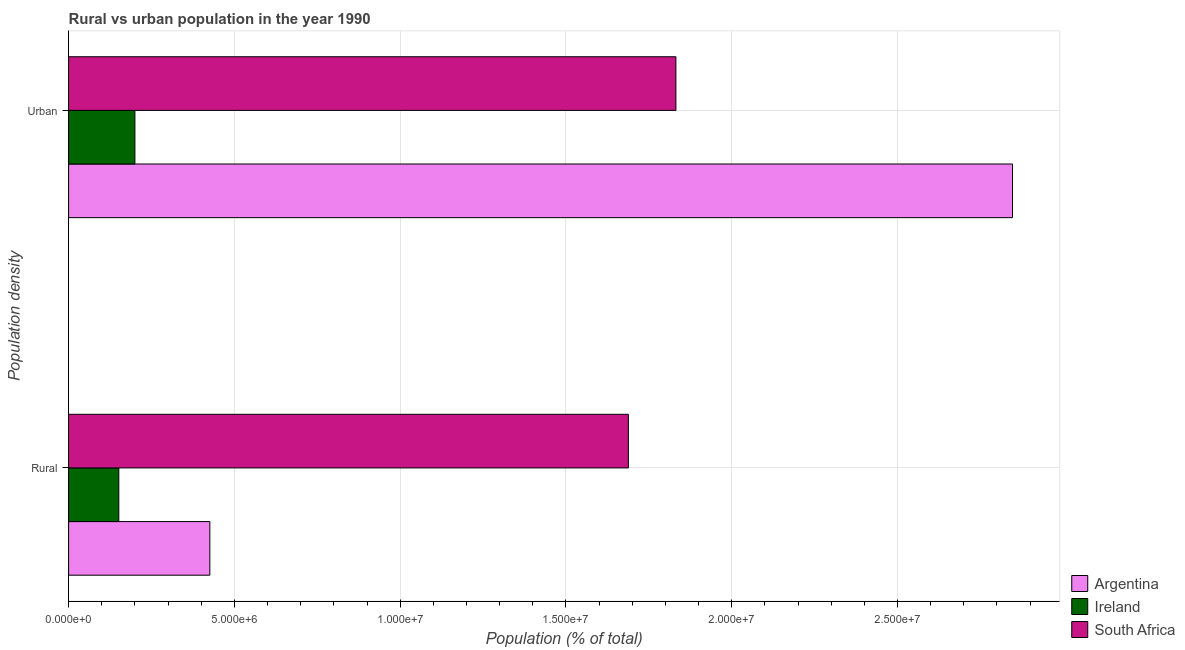How many groups of bars are there?
Your answer should be compact. 2. Are the number of bars per tick equal to the number of legend labels?
Make the answer very short. Yes. What is the label of the 1st group of bars from the top?
Make the answer very short. Urban. What is the urban population density in South Africa?
Provide a short and direct response. 1.83e+07. Across all countries, what is the maximum rural population density?
Offer a very short reply. 1.69e+07. Across all countries, what is the minimum urban population density?
Provide a succinct answer. 2.00e+06. In which country was the rural population density minimum?
Provide a short and direct response. Ireland. What is the total rural population density in the graph?
Your response must be concise. 2.27e+07. What is the difference between the urban population density in Argentina and that in South Africa?
Provide a short and direct response. 1.02e+07. What is the difference between the rural population density in Argentina and the urban population density in Ireland?
Your response must be concise. 2.26e+06. What is the average urban population density per country?
Provide a succinct answer. 1.63e+07. What is the difference between the rural population density and urban population density in Ireland?
Your response must be concise. -4.85e+05. What is the ratio of the urban population density in South Africa to that in Argentina?
Your response must be concise. 0.64. In how many countries, is the rural population density greater than the average rural population density taken over all countries?
Ensure brevity in your answer.  1. What does the 3rd bar from the top in Rural represents?
Keep it short and to the point. Argentina. What does the 2nd bar from the bottom in Rural represents?
Ensure brevity in your answer.  Ireland. Are all the bars in the graph horizontal?
Offer a very short reply. Yes. How many countries are there in the graph?
Your answer should be very brief. 3. What is the difference between two consecutive major ticks on the X-axis?
Offer a very short reply. 5.00e+06. Are the values on the major ticks of X-axis written in scientific E-notation?
Your response must be concise. Yes. How are the legend labels stacked?
Provide a succinct answer. Vertical. What is the title of the graph?
Offer a very short reply. Rural vs urban population in the year 1990. What is the label or title of the X-axis?
Keep it short and to the point. Population (% of total). What is the label or title of the Y-axis?
Your answer should be very brief. Population density. What is the Population (% of total) in Argentina in Rural?
Offer a very short reply. 4.26e+06. What is the Population (% of total) in Ireland in Rural?
Offer a terse response. 1.51e+06. What is the Population (% of total) in South Africa in Rural?
Your response must be concise. 1.69e+07. What is the Population (% of total) of Argentina in Urban?
Ensure brevity in your answer.  2.85e+07. What is the Population (% of total) in Ireland in Urban?
Provide a short and direct response. 2.00e+06. What is the Population (% of total) of South Africa in Urban?
Make the answer very short. 1.83e+07. Across all Population density, what is the maximum Population (% of total) of Argentina?
Provide a short and direct response. 2.85e+07. Across all Population density, what is the maximum Population (% of total) in Ireland?
Keep it short and to the point. 2.00e+06. Across all Population density, what is the maximum Population (% of total) of South Africa?
Your answer should be very brief. 1.83e+07. Across all Population density, what is the minimum Population (% of total) in Argentina?
Offer a very short reply. 4.26e+06. Across all Population density, what is the minimum Population (% of total) of Ireland?
Keep it short and to the point. 1.51e+06. Across all Population density, what is the minimum Population (% of total) of South Africa?
Your answer should be compact. 1.69e+07. What is the total Population (% of total) of Argentina in the graph?
Ensure brevity in your answer.  3.27e+07. What is the total Population (% of total) of Ireland in the graph?
Your answer should be very brief. 3.51e+06. What is the total Population (% of total) of South Africa in the graph?
Offer a terse response. 3.52e+07. What is the difference between the Population (% of total) of Argentina in Rural and that in Urban?
Your answer should be compact. -2.42e+07. What is the difference between the Population (% of total) in Ireland in Rural and that in Urban?
Your answer should be very brief. -4.85e+05. What is the difference between the Population (% of total) of South Africa in Rural and that in Urban?
Your answer should be very brief. -1.43e+06. What is the difference between the Population (% of total) in Argentina in Rural and the Population (% of total) in Ireland in Urban?
Your response must be concise. 2.26e+06. What is the difference between the Population (% of total) of Argentina in Rural and the Population (% of total) of South Africa in Urban?
Offer a very short reply. -1.41e+07. What is the difference between the Population (% of total) of Ireland in Rural and the Population (% of total) of South Africa in Urban?
Your answer should be very brief. -1.68e+07. What is the average Population (% of total) of Argentina per Population density?
Provide a succinct answer. 1.64e+07. What is the average Population (% of total) of Ireland per Population density?
Keep it short and to the point. 1.76e+06. What is the average Population (% of total) in South Africa per Population density?
Give a very brief answer. 1.76e+07. What is the difference between the Population (% of total) of Argentina and Population (% of total) of Ireland in Rural?
Ensure brevity in your answer.  2.75e+06. What is the difference between the Population (% of total) of Argentina and Population (% of total) of South Africa in Rural?
Offer a very short reply. -1.26e+07. What is the difference between the Population (% of total) of Ireland and Population (% of total) of South Africa in Rural?
Offer a very short reply. -1.54e+07. What is the difference between the Population (% of total) of Argentina and Population (% of total) of Ireland in Urban?
Give a very brief answer. 2.65e+07. What is the difference between the Population (% of total) of Argentina and Population (% of total) of South Africa in Urban?
Ensure brevity in your answer.  1.02e+07. What is the difference between the Population (% of total) in Ireland and Population (% of total) in South Africa in Urban?
Make the answer very short. -1.63e+07. What is the ratio of the Population (% of total) in Argentina in Rural to that in Urban?
Make the answer very short. 0.15. What is the ratio of the Population (% of total) of Ireland in Rural to that in Urban?
Your answer should be very brief. 0.76. What is the ratio of the Population (% of total) in South Africa in Rural to that in Urban?
Ensure brevity in your answer.  0.92. What is the difference between the highest and the second highest Population (% of total) of Argentina?
Keep it short and to the point. 2.42e+07. What is the difference between the highest and the second highest Population (% of total) of Ireland?
Ensure brevity in your answer.  4.85e+05. What is the difference between the highest and the second highest Population (% of total) of South Africa?
Keep it short and to the point. 1.43e+06. What is the difference between the highest and the lowest Population (% of total) of Argentina?
Keep it short and to the point. 2.42e+07. What is the difference between the highest and the lowest Population (% of total) of Ireland?
Your answer should be very brief. 4.85e+05. What is the difference between the highest and the lowest Population (% of total) of South Africa?
Your answer should be compact. 1.43e+06. 